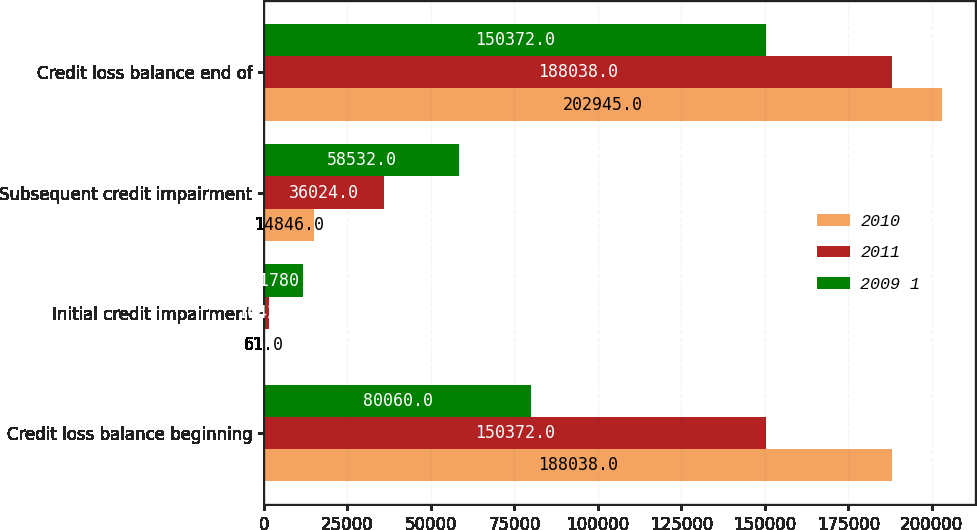<chart> <loc_0><loc_0><loc_500><loc_500><stacked_bar_chart><ecel><fcel>Credit loss balance beginning<fcel>Initial credit impairment<fcel>Subsequent credit impairment<fcel>Credit loss balance end of<nl><fcel>2010<fcel>188038<fcel>61<fcel>14846<fcel>202945<nl><fcel>2011<fcel>150372<fcel>1642<fcel>36024<fcel>188038<nl><fcel>2009 1<fcel>80060<fcel>11780<fcel>58532<fcel>150372<nl></chart> 